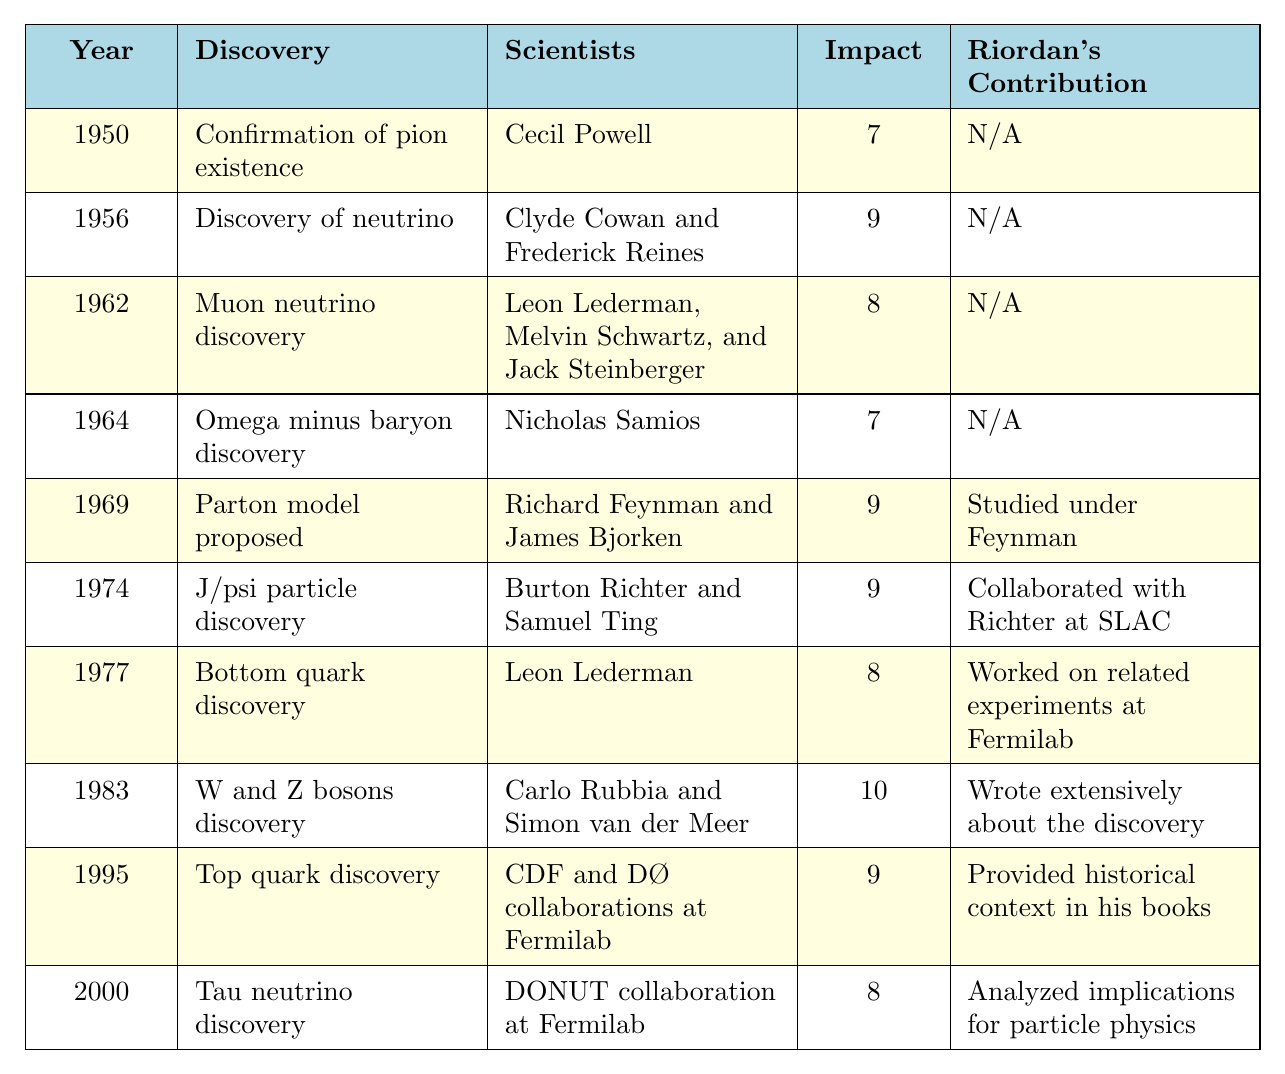What was the discovery made in 1964? The table shows that in 1964, the discovery made was the Omega minus baryon.
Answer: Omega minus baryon discovery Which scientists were involved in the 1974 discovery? According to the table, the J/psi particle was discovered in 1974 by Burton Richter and Samuel Ting.
Answer: Burton Richter and Samuel Ting What is the impact score of the 1983 discovery? The table indicates that the discovery of W and Z bosons in 1983 has an impact score of 10.
Answer: 10 Did Michael Riordan contribute to the discovery of the bottom quark? Looking at the table, it shows that Riordan worked on related experiments at Fermilab for the bottom quark discovery in 1977. This indicates that he had some contribution.
Answer: Yes Which discovery has the highest impact score, and who were the scientists behind it? The highest impact score is 10, which corresponds to the discovery of W and Z bosons in 1983 by Carlo Rubbia and Simon van der Meer.
Answer: W and Z bosons; Carlo Rubbia and Simon van der Meer What was the average impact score of discoveries made in the 1970s? The impact scores for the discoveries in the 1970s (1974 - 1977) are 9 (J/psi), 8 (Bottom quark). The average is (9 + 8) / 2 = 8.5.
Answer: 8.5 What year did the Tau neutrino get discovered, and what was its impact score? According to the table, the Tau neutrino was discovered in 2000, with an impact score of 8.
Answer: 2000; 8 How many discoveries have an impact score of 9, and what are their names? By examining the table, there are 4 discoveries with an impact score of 9: neutrino (1956), parton model (1969), J/psi particle (1974), and W and Z bosons (1983).
Answer: 4; neutrino, parton model, J/psi particle, W and Z bosons Was there a contribution from Michael Riordan for the discovery of the tau neutrino? The table specifies that the contribution of Riordan for the tau neutrino discovery in 2000 was to analyze implications for particle physics, indicating he had a contribution.
Answer: Yes Which scientist collaborated with Burton Richter? The table indicates that Samuel Ting collaborated with Burton Richter during the J/psi particle discovery in 1974.
Answer: Samuel Ting 